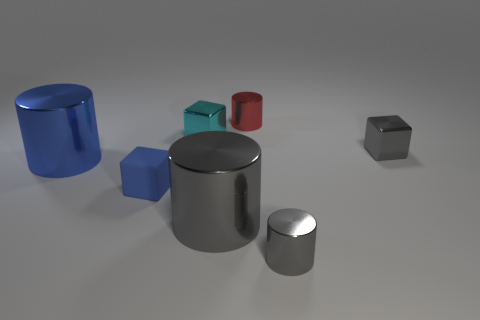Are any of these objects capable of holding liquid? Looking at the image, the large blue cylinder has characteristics of a container which could potentially hold liquid, given its open top and hollow structure. Which objects appear to have a reflective surface? The small shiny black cube and the larger silver cylinder exhibit reflective surfaces as indicated by the light patterns on their exterior, suggesting that they have a polished finish. 